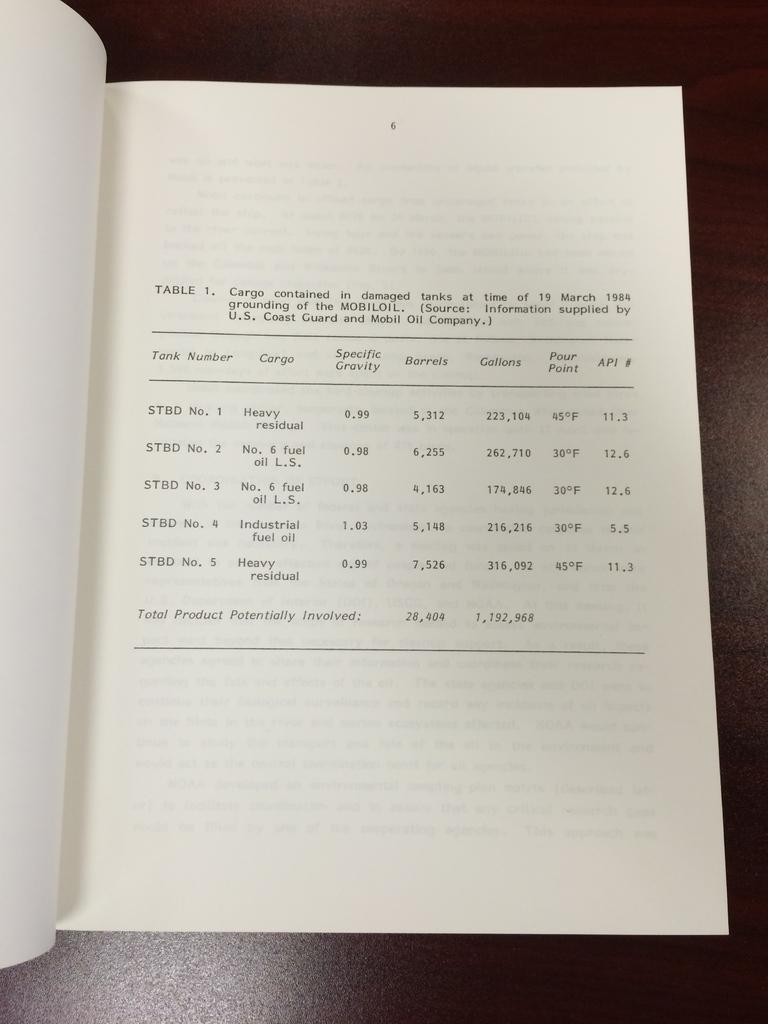<image>
Describe the image concisely. A book is open and the right page shows table 1. 